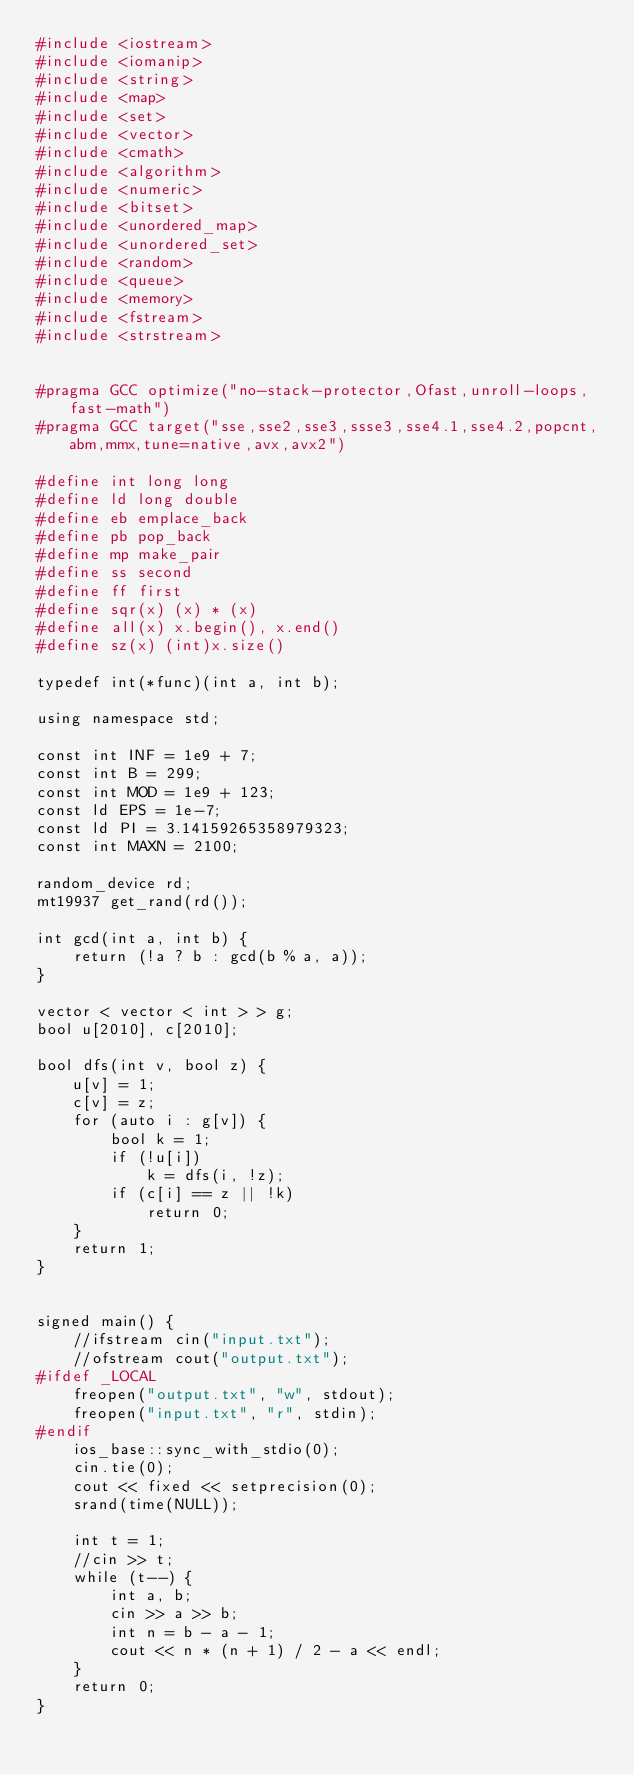<code> <loc_0><loc_0><loc_500><loc_500><_Python_>#include <iostream>
#include <iomanip>
#include <string>
#include <map>
#include <set>
#include <vector>
#include <cmath>
#include <algorithm>
#include <numeric>
#include <bitset>
#include <unordered_map>
#include <unordered_set>
#include <random>
#include <queue>
#include <memory>
#include <fstream>
#include <strstream>


#pragma GCC optimize("no-stack-protector,Ofast,unroll-loops,fast-math")
#pragma GCC target("sse,sse2,sse3,ssse3,sse4.1,sse4.2,popcnt,abm,mmx,tune=native,avx,avx2")

#define int long long
#define ld long double
#define eb emplace_back
#define pb pop_back
#define mp make_pair
#define ss second
#define ff first
#define sqr(x) (x) * (x)
#define all(x) x.begin(), x.end()
#define sz(x) (int)x.size()

typedef int(*func)(int a, int b);

using namespace std;

const int INF = 1e9 + 7;
const int B = 299;
const int MOD = 1e9 + 123;
const ld EPS = 1e-7;
const ld PI = 3.14159265358979323;
const int MAXN = 2100;

random_device rd;
mt19937 get_rand(rd());

int gcd(int a, int b) {
	return (!a ? b : gcd(b % a, a));
}

vector < vector < int > > g;
bool u[2010], c[2010];

bool dfs(int v, bool z) {
	u[v] = 1;
	c[v] = z;
	for (auto i : g[v]) {
		bool k = 1;
		if (!u[i])
			k = dfs(i, !z);
		if (c[i] == z || !k)
			return 0;
	}
	return 1;
}


signed main() {
	//ifstream cin("input.txt");
	//ofstream cout("output.txt");
#ifdef _LOCAL
	freopen("output.txt", "w", stdout);
	freopen("input.txt", "r", stdin);
#endif
	ios_base::sync_with_stdio(0);
	cin.tie(0);
	cout << fixed << setprecision(0);
	srand(time(NULL));

	int t = 1;
	//cin >> t;
	while (t--) {
		int a, b;
		cin >> a >> b;
		int n = b - a - 1;
		cout << n * (n + 1) / 2 - a << endl;
	}
	return 0;
}</code> 